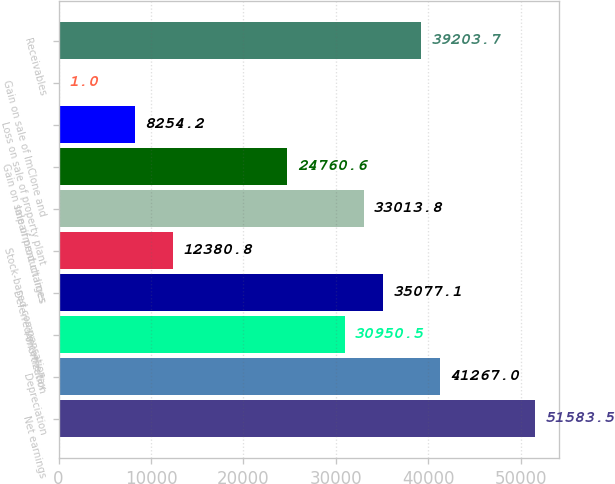<chart> <loc_0><loc_0><loc_500><loc_500><bar_chart><fcel>Net earnings<fcel>Depreciation<fcel>Amortization<fcel>Deferred income tax<fcel>Stock-based compensation<fcel>Impairment charges<fcel>Gain on sale of product lines<fcel>Loss on sale of property plant<fcel>Gain on sale of ImClone and<fcel>Receivables<nl><fcel>51583.5<fcel>41267<fcel>30950.5<fcel>35077.1<fcel>12380.8<fcel>33013.8<fcel>24760.6<fcel>8254.2<fcel>1<fcel>39203.7<nl></chart> 